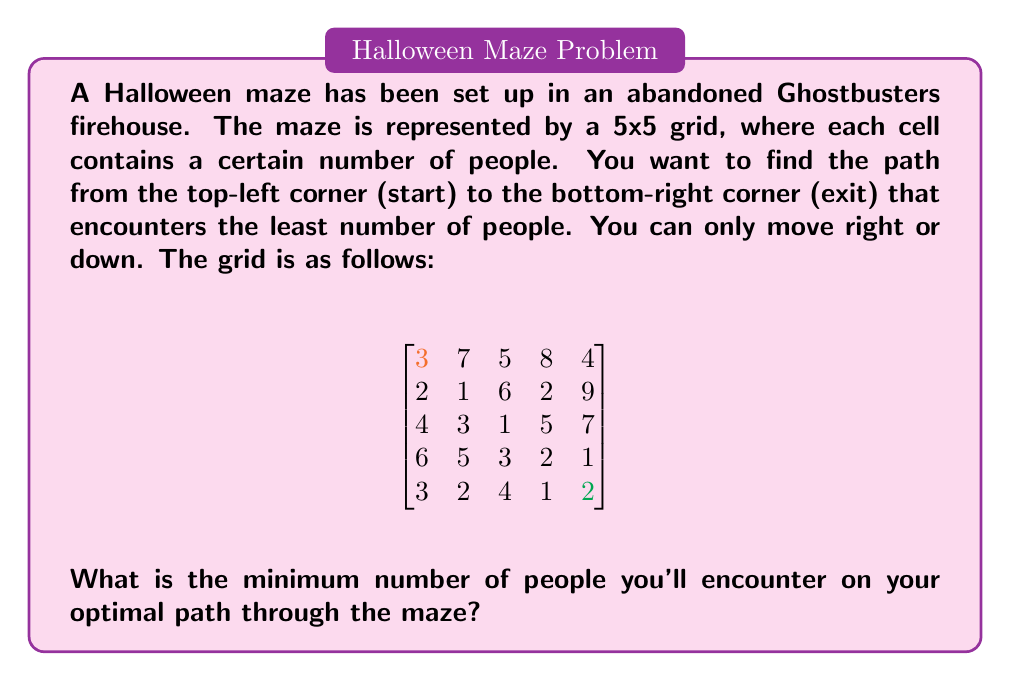Solve this math problem. To solve this problem, we'll use dynamic programming. We'll create a new matrix that stores the minimum number of people encountered to reach each cell from the start.

Step 1: Initialize the first row and column of the new matrix.
- First row: Cumulative sum of people from left to right
- First column: Cumulative sum of people from top to bottom

$$
\begin{bmatrix}
3 & 10 & 15 & 23 & 27 \\
5 & * & * & * & * \\
9 & * & * & * & * \\
15 & * & * & * & * \\
18 & * & * & * & *
\end{bmatrix}
$$

Step 2: Fill in the rest of the matrix. For each cell, choose the minimum between coming from above or from the left, and add the number of people in the current cell.

$$
\begin{bmatrix}
3 & 10 & 15 & 23 & 27 \\
5 & 11 & 17 & 19 & 28 \\
9 & 12 & 13 & 18 & 25 \\
15 & 17 & 16 & 18 & 19 \\
18 & 19 & 20 & 19 & 21
\end{bmatrix}
$$

Step 3: The bottom-right cell now contains the minimum number of people encountered on the optimal path.

Therefore, the minimum number of people encountered is 21.

The optimal path can be traced backwards from the bottom-right cell, always choosing the smaller of the two possible previous cells. This path is:
(1,1) → (1,2) → (2,2) → (3,2) → (3,3) → (4,3) → (4,4) → (5,4) → (5,5)
Answer: 21 